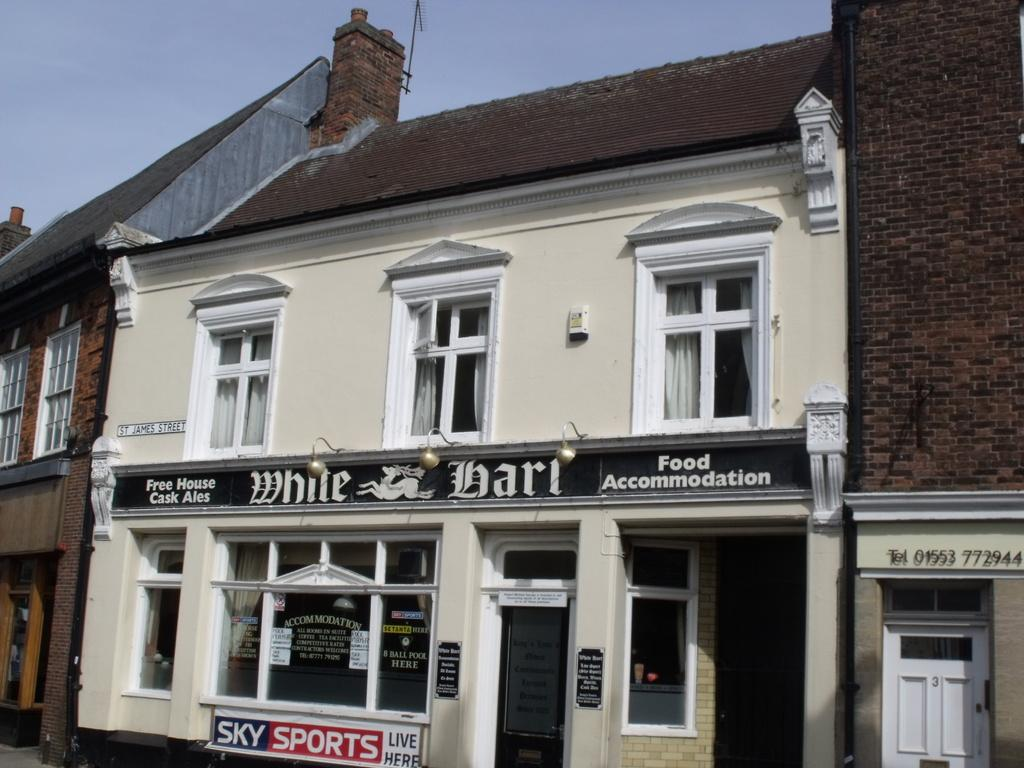What type of structures can be seen in the image? There are buildings in the image. What architectural features are visible on the buildings? There are windows and a door visible on the buildings. What additional object can be seen in the image? There is a banner in the image. What can be seen in the sky in the image? The sky is visible in the image. Can you tell me what type of bread is floating in the lake in the image? There is no bread or lake present in the image; it features buildings, windows, a door, a banner, and the sky. 